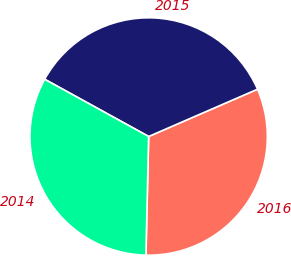Convert chart to OTSL. <chart><loc_0><loc_0><loc_500><loc_500><pie_chart><fcel>2016<fcel>2015<fcel>2014<nl><fcel>31.89%<fcel>35.47%<fcel>32.64%<nl></chart> 